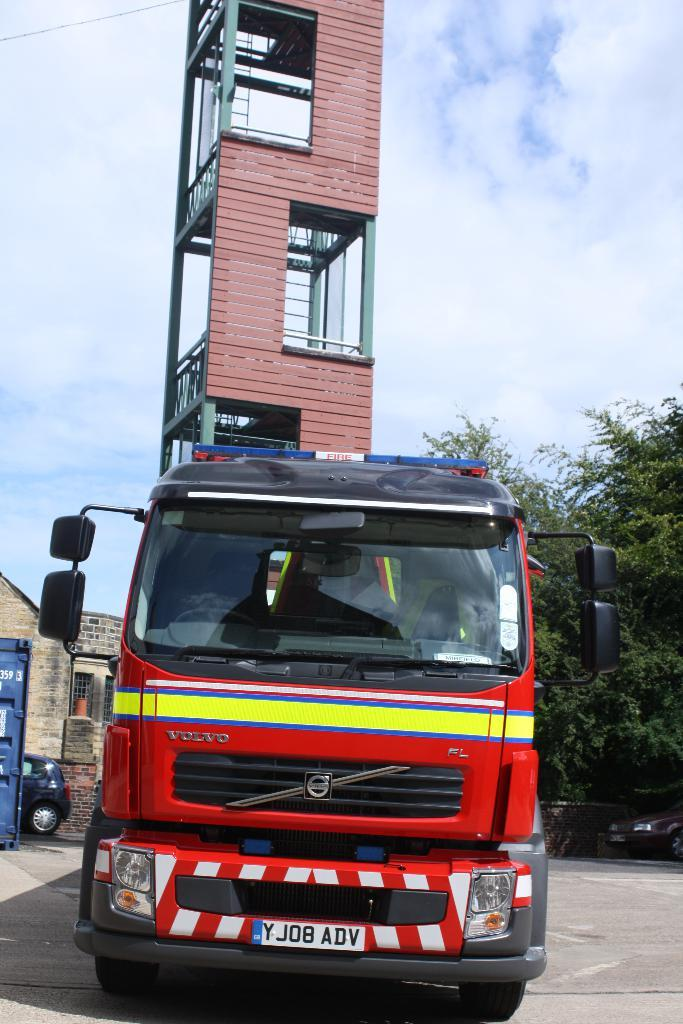What is the color of the vehicle on the road? The vehicle on the road is red. What can be seen in the background of the image? There are trees, a tower, another vehicle, and a building in the background. What is the color of the sky in the image? The sky is blue with clouds in the image. What type of vest is the church wearing in the image? There is no church or vest present in the image. 